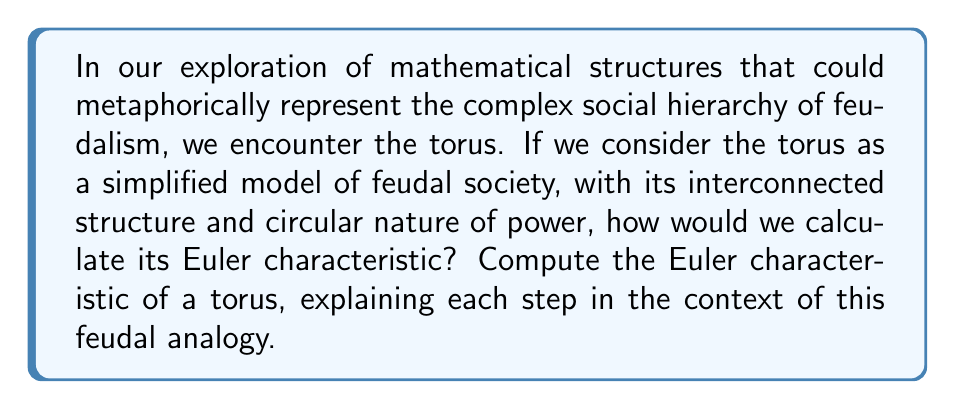Could you help me with this problem? To compute the Euler characteristic of a torus, we'll follow these steps:

1. Recall the formula for the Euler characteristic:
   $$\chi = V - E + F$$
   where $V$ is the number of vertices, $E$ is the number of edges, and $F$ is the number of faces.

2. Visualize the torus as a rectangular grid with opposite edges identified:
   [asy]
   unitsize(1cm);
   path p = (0,0)--(4,0)--(4,3)--(0,3)--cycle;
   draw(p);
   for(int i=1; i<4; ++i) draw((i,0)--(i,3));
   for(int j=1; j<3; ++j) draw((0,j)--(4,j));
   label("A", (0,0), SW);
   label("A", (4,0), SE);
   label("A", (0,3), NW);
   label("A", (4,3), NE);
   label("B", (0,1.5), W);
   label("B", (4,1.5), E);
   label("C", (2,0), S);
   label("C", (2,3), N);
   [/asy]

3. Count the components:
   - Vertices: All corner points are identified (A), so there's only 1 vertex.
   - Edges: The top and bottom edges are identified (C), and the left and right edges are identified (B). The internal grid lines form 2 additional edges. So, there are 4 edges total.
   - Faces: There's only 1 face, as all cells of the grid are connected on the surface of the torus.

4. Apply the Euler characteristic formula:
   $$\chi = V - E + F = 1 - 4 + 1 = -2$$

In our feudal analogy:
- The single vertex (A) represents the monarch at the top of the hierarchy.
- The edges (B and C) represent the interconnected relationships between different levels of society.
- The single face represents the continuous nature of the feudal system, where all parts are interconnected.

The negative Euler characteristic (-2) could be interpreted as the inherent tension or "deficit" in the feudal system, reflecting its complex and sometimes contradictory nature.
Answer: The Euler characteristic of a torus is $\chi = -2$. 